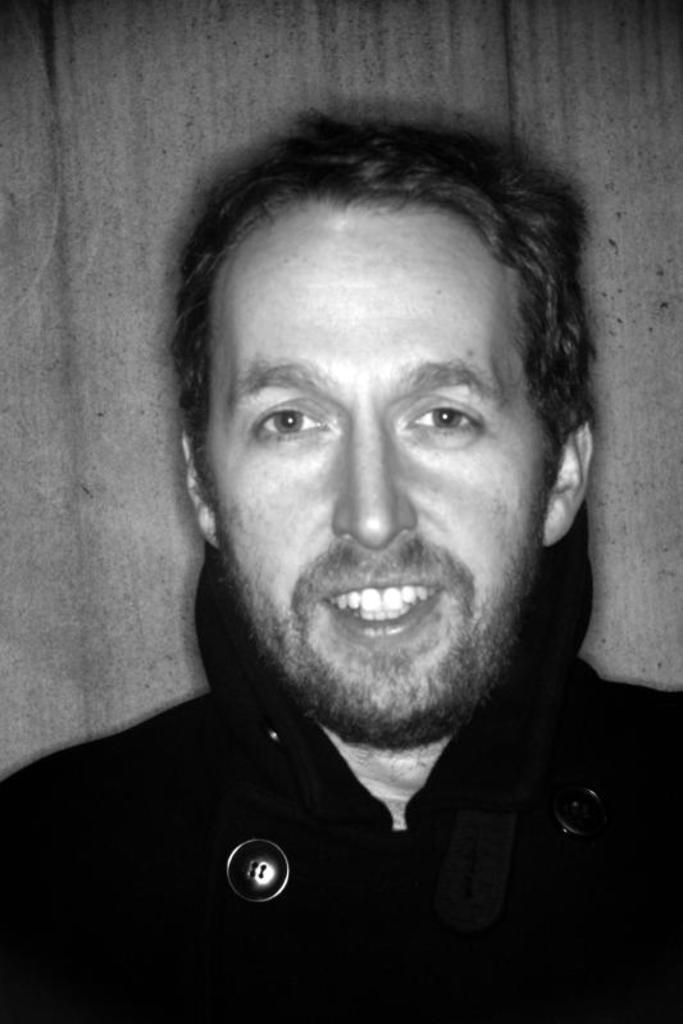What is present in the image? There is a man in the image. Can you describe the man's appearance? The man is wearing clothes and smiling. What other object is present in the image? There is a button in the image. What type of toy can be seen in the image? There is no toy present in the image. Is the man holding a camera in the image? There is no camera present in the image. Can you see a yoke in the image? There is no yoke present in the image. 